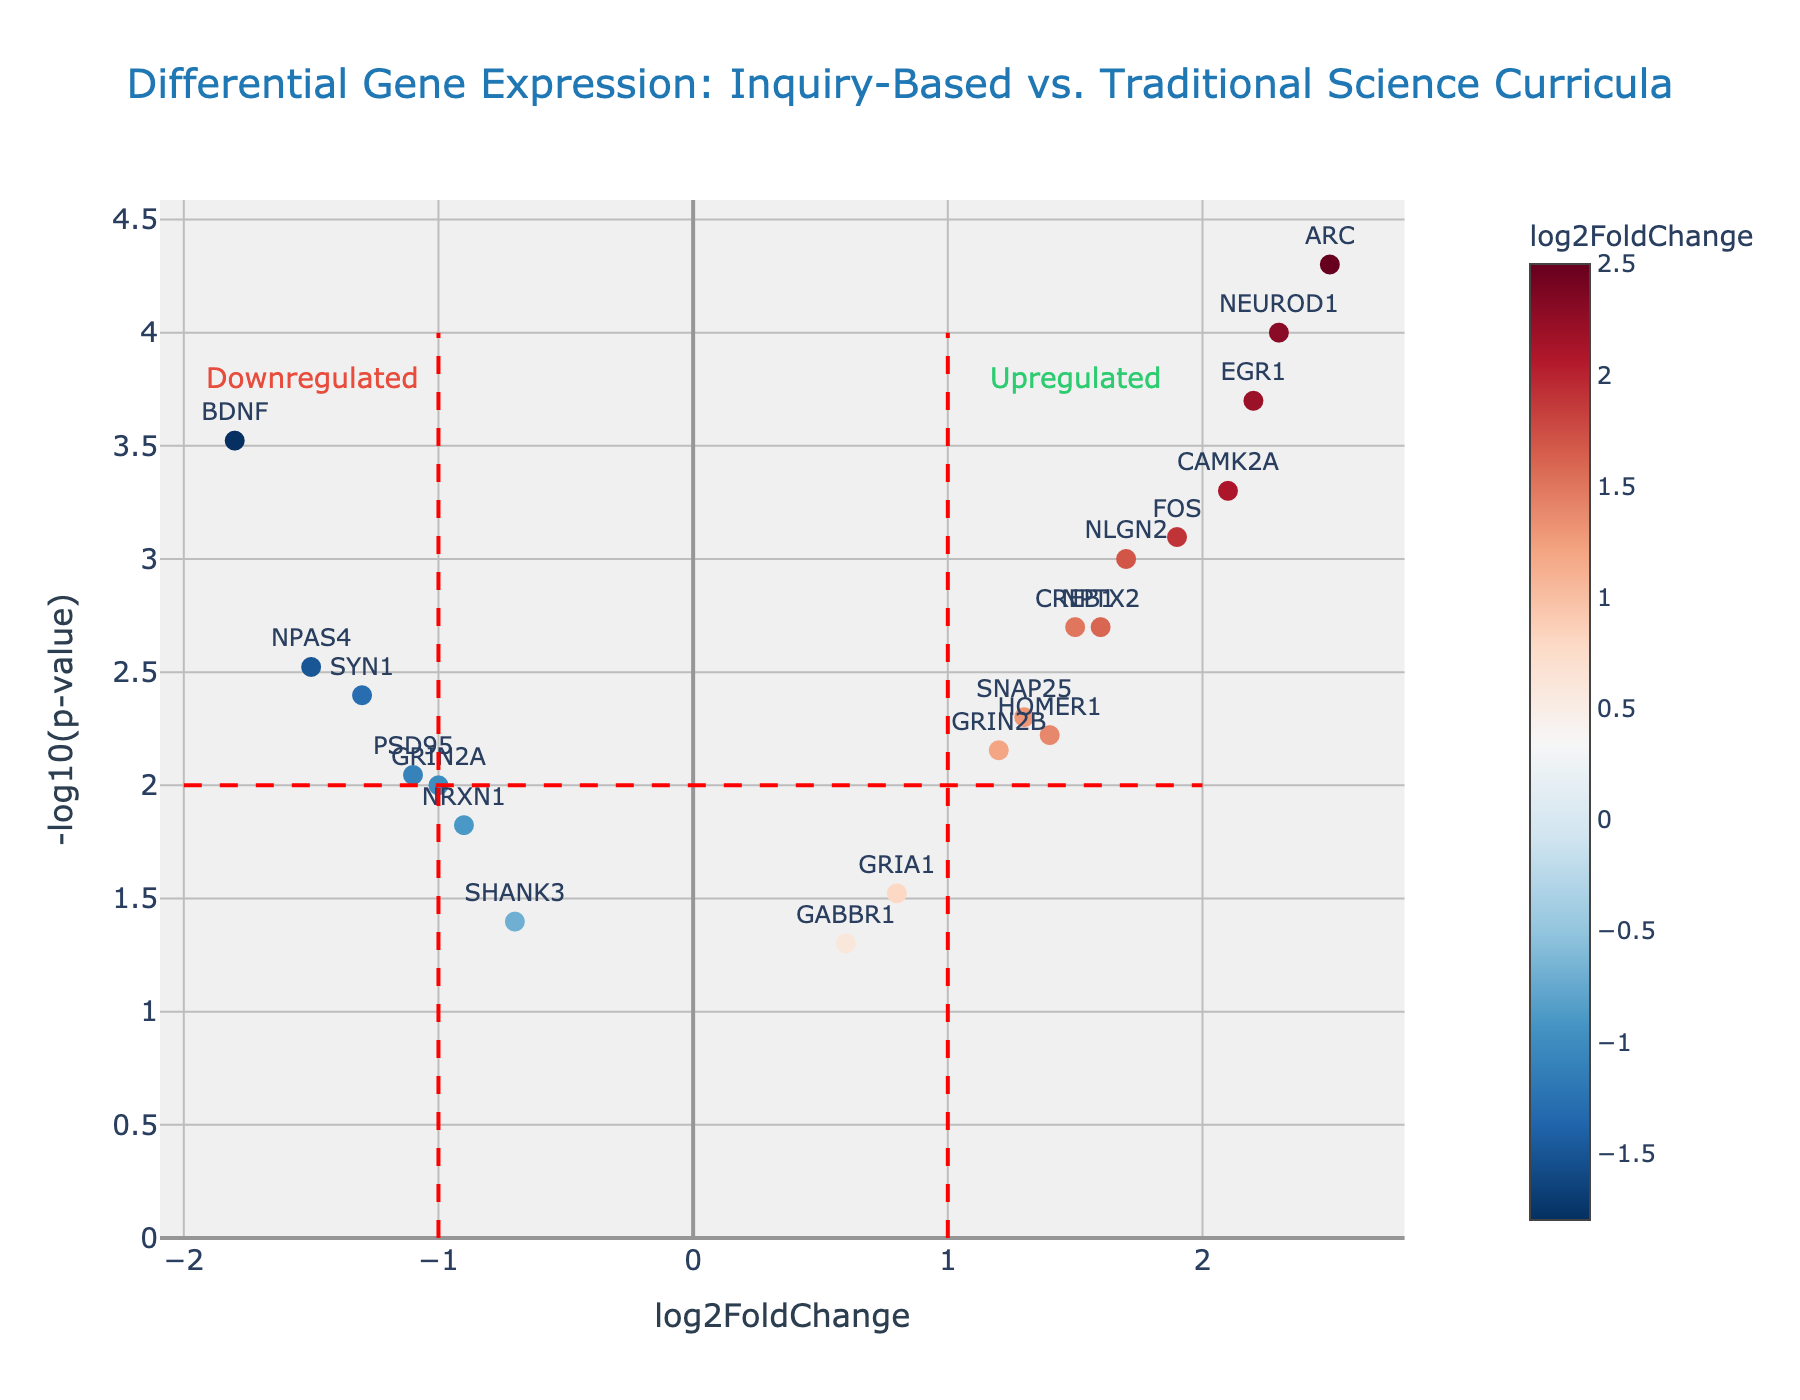Which gene has the highest -log10(p-value)? To determine which gene has the highest -log10(p-value), look for the data point that is highest on the y-axis.
Answer: ARC What is the range of log2FoldChange values for the genes shown in the plot? To identify the range, find the minimum and maximum log2FoldChange values among the genes. The minimum is -1.8 (BDNF), and the maximum is 2.5 (ARC). Thus, the range is from -1.8 to 2.5.
Answer: -1.8 to 2.5 How many genes are upregulated (log2FoldChange > 1)? Count the number of data points with log2FoldChange values greater than 1. These are NEUROD1, CREB1, CAMK2A, GRIN2B, NLGN2, ARC, EGR1, NPTX2, SNAP25. There are 9 such genes.
Answer: 9 Which genes have a log2FoldChange value between -1 and 1? Look at the data points within the -1 to 1 range on the x-axis. These genes are NRXN1, GRIA1, PSD95, HOMER1, SHANK3, GRIN2A, GABBR1.
Answer: NRXN1, GRIA1, PSD95, HOMER1, SHANK3, GRIN2A, GABBR1 Is there a gene that is less significant (higher p-value) and slightly downregulated (log2FoldChange between -1 and 0)? Identify a data point with log2FoldChange between -1 and 0 and with a relatively higher p-value (lower -log10(p-value)). The gene SHANK3 fits this description.
Answer: SHANK3 What is the p-value of the gene NEUROD1? To find the p-value of NEUROD1, refer to its data point and hover text or calculate reverse of -log10(p-value). The -log10(p-value) is 4, reverse gives 10^-4.
Answer: 0.0001 Do more genes fall into the upregulated or downregulated category? Compare the number of genes with log2FoldChange > 0 (upregulated) to those with log2FoldChange < 0 (downregulated). There are more upregulated genes (12) than downregulated (7).
Answer: Upregulated Which side, left or right of log2FoldChange = 0, contains more significant genes (lower p-values)? Compare the significance values (-log10(p-value)) of genes on the left (log2FoldChange < 0) and right (log2FoldChange > 0) of the plot. The right side (upregulated) has more significant genes overall.
Answer: Right Which gene exhibits the closest balance between its differential expression and p-value (consider both scales)? By assessing both log2FoldChange and -log10(p-value), HOMER1 shows a middle-ground balance with log2FoldChange of 1.4 and -log10(p-value) of 2.2.
Answer: HOMER1 